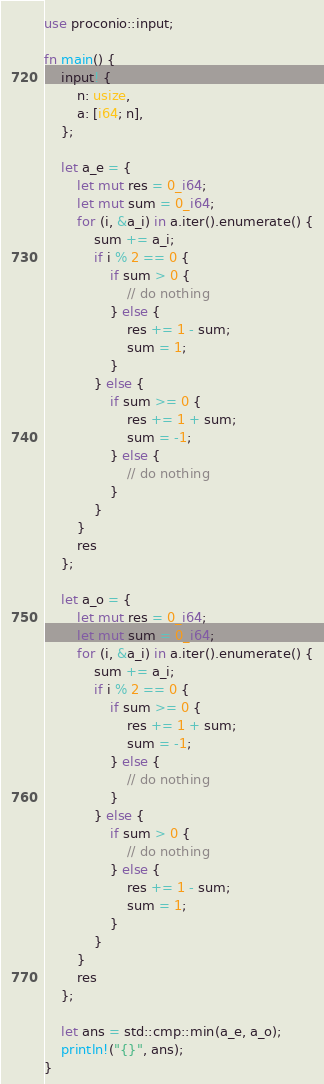<code> <loc_0><loc_0><loc_500><loc_500><_Rust_>use proconio::input;

fn main() {
    input! {
        n: usize,
        a: [i64; n],
    };

    let a_e = {
        let mut res = 0_i64;
        let mut sum = 0_i64;
        for (i, &a_i) in a.iter().enumerate() {
            sum += a_i;
            if i % 2 == 0 {
                if sum > 0 {
                    // do nothing
                } else {
                    res += 1 - sum;
                    sum = 1;
                }
            } else {
                if sum >= 0 {
                    res += 1 + sum;
                    sum = -1;
                } else {
                    // do nothing
                }
            }
        }
        res
    };

    let a_o = {
        let mut res = 0_i64;
        let mut sum = 0_i64;
        for (i, &a_i) in a.iter().enumerate() {
            sum += a_i;
            if i % 2 == 0 {
                if sum >= 0 {
                    res += 1 + sum;
                    sum = -1;
                } else {
                    // do nothing
                }
            } else {
                if sum > 0 {
                    // do nothing
                } else {
                    res += 1 - sum;
                    sum = 1;
                }
            }
        }
        res
    };

    let ans = std::cmp::min(a_e, a_o);
    println!("{}", ans);
}
</code> 